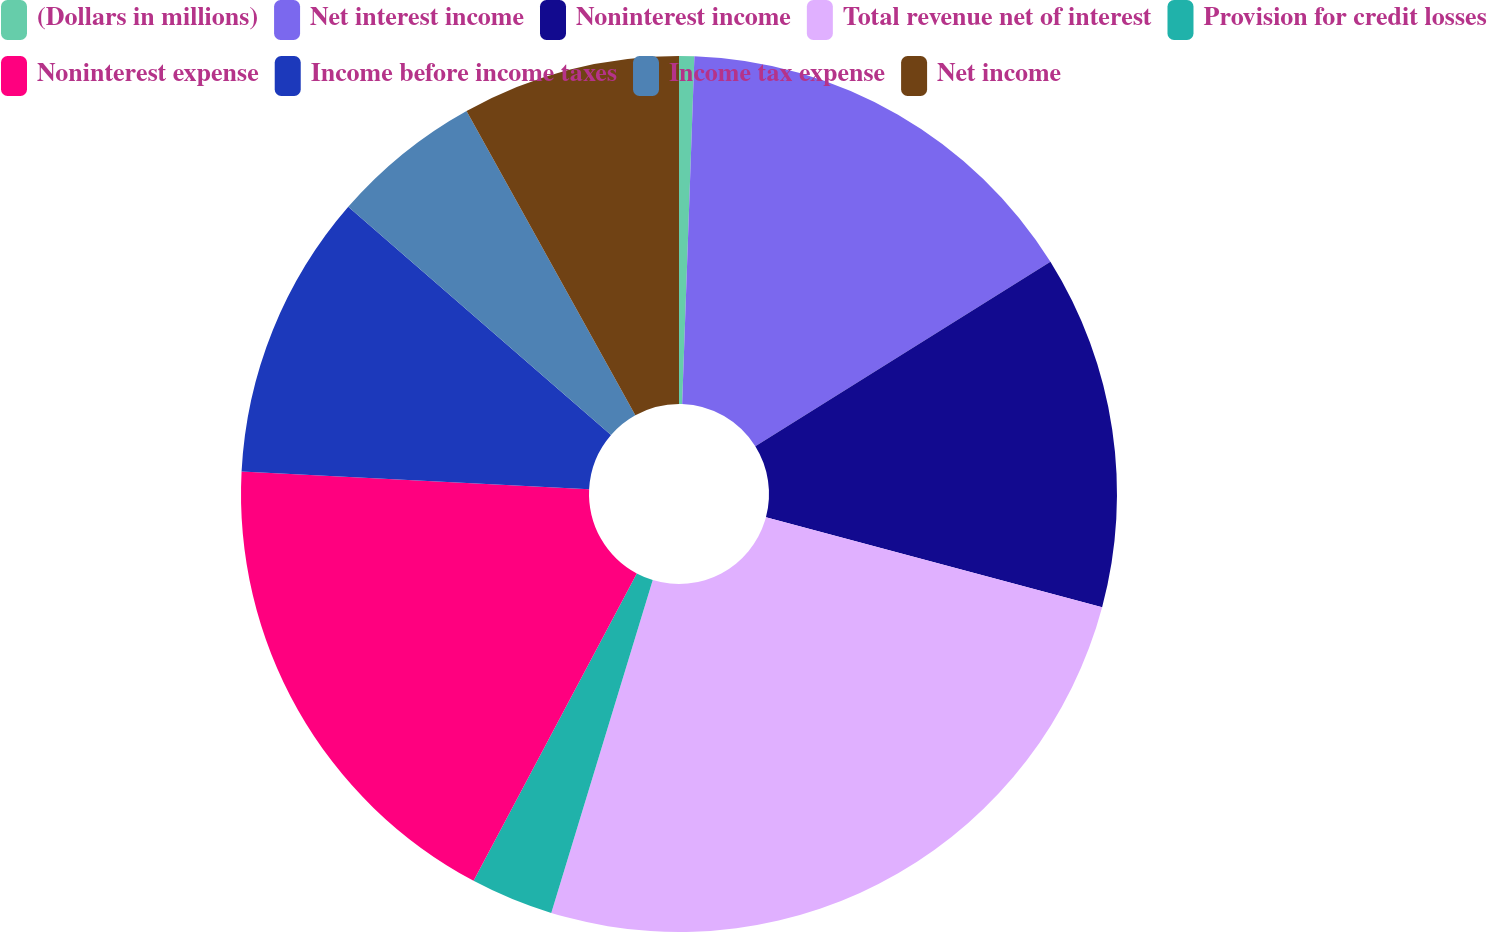Convert chart to OTSL. <chart><loc_0><loc_0><loc_500><loc_500><pie_chart><fcel>(Dollars in millions)<fcel>Net interest income<fcel>Noninterest income<fcel>Total revenue net of interest<fcel>Provision for credit losses<fcel>Noninterest expense<fcel>Income before income taxes<fcel>Income tax expense<fcel>Net income<nl><fcel>0.56%<fcel>15.55%<fcel>13.05%<fcel>25.55%<fcel>3.06%<fcel>18.05%<fcel>10.56%<fcel>5.56%<fcel>8.06%<nl></chart> 